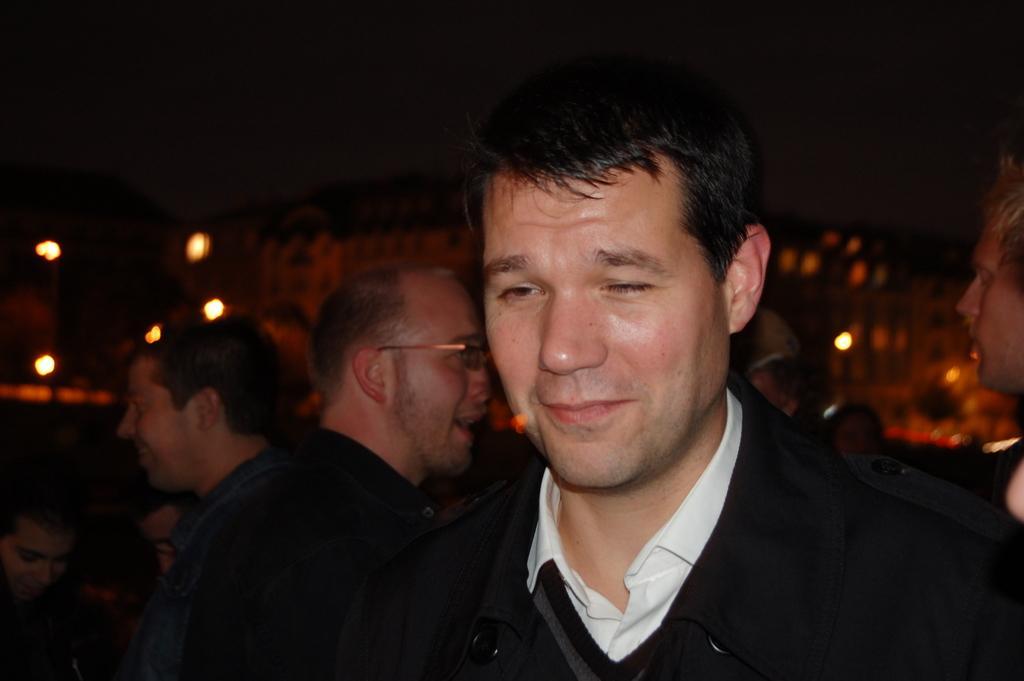How would you summarize this image in a sentence or two? In this image we can see a few people, there are buildings, lights, and the background is blurred. 